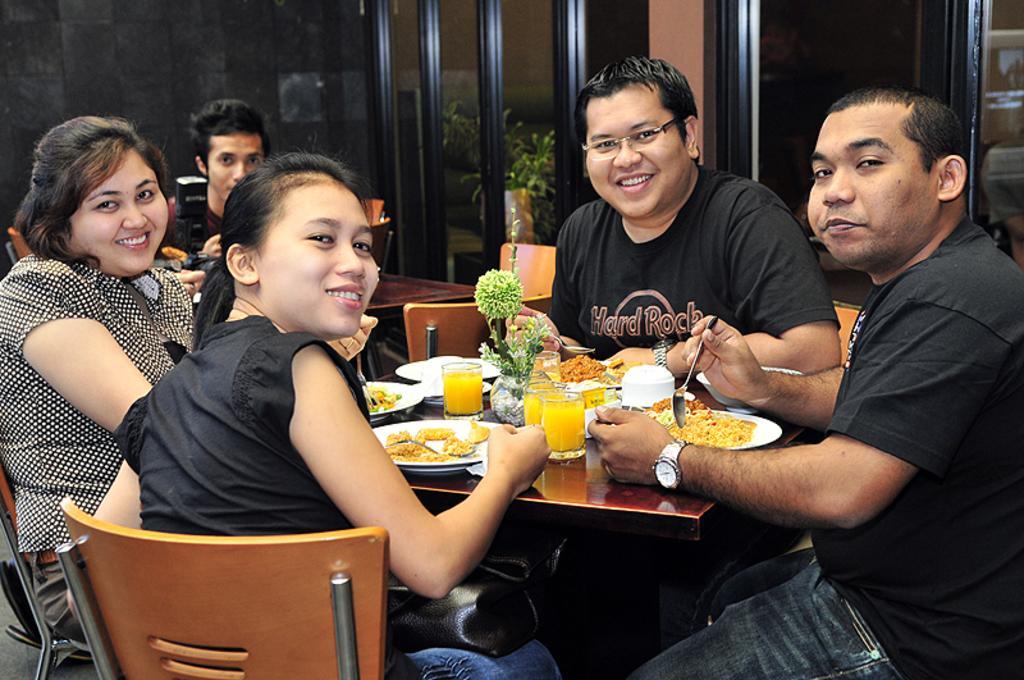Please provide a concise description of this image. In a room there are people sitting on a chairs in front of table there is food served in plate with glasses of juice and flower vase. 